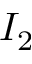<formula> <loc_0><loc_0><loc_500><loc_500>I _ { 2 }</formula> 